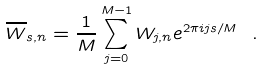Convert formula to latex. <formula><loc_0><loc_0><loc_500><loc_500>\overline { W } _ { s , n } = \frac { 1 } { M } \sum _ { j = 0 } ^ { M - 1 } W _ { j , n } e ^ { 2 \pi i j s / M } \ .</formula> 